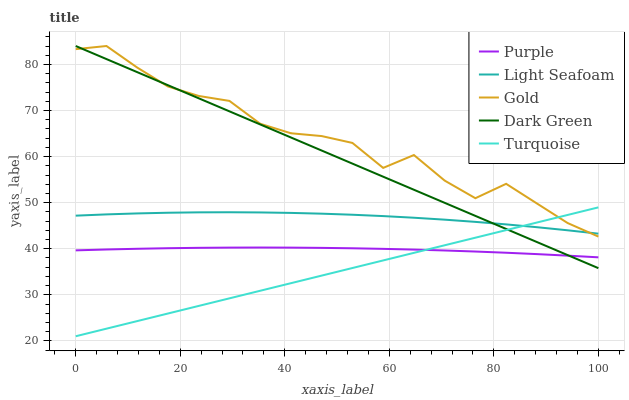Does Turquoise have the minimum area under the curve?
Answer yes or no. Yes. Does Gold have the maximum area under the curve?
Answer yes or no. Yes. Does Light Seafoam have the minimum area under the curve?
Answer yes or no. No. Does Light Seafoam have the maximum area under the curve?
Answer yes or no. No. Is Turquoise the smoothest?
Answer yes or no. Yes. Is Gold the roughest?
Answer yes or no. Yes. Is Light Seafoam the smoothest?
Answer yes or no. No. Is Light Seafoam the roughest?
Answer yes or no. No. Does Light Seafoam have the lowest value?
Answer yes or no. No. Does Dark Green have the highest value?
Answer yes or no. Yes. Does Turquoise have the highest value?
Answer yes or no. No. Is Purple less than Light Seafoam?
Answer yes or no. Yes. Is Gold greater than Purple?
Answer yes or no. Yes. Does Dark Green intersect Turquoise?
Answer yes or no. Yes. Is Dark Green less than Turquoise?
Answer yes or no. No. Is Dark Green greater than Turquoise?
Answer yes or no. No. Does Purple intersect Light Seafoam?
Answer yes or no. No. 